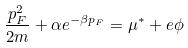<formula> <loc_0><loc_0><loc_500><loc_500>\frac { p _ { F } ^ { 2 } } { 2 m } + \alpha e ^ { - \beta p _ { F } } = \mu ^ { * } + e \phi</formula> 